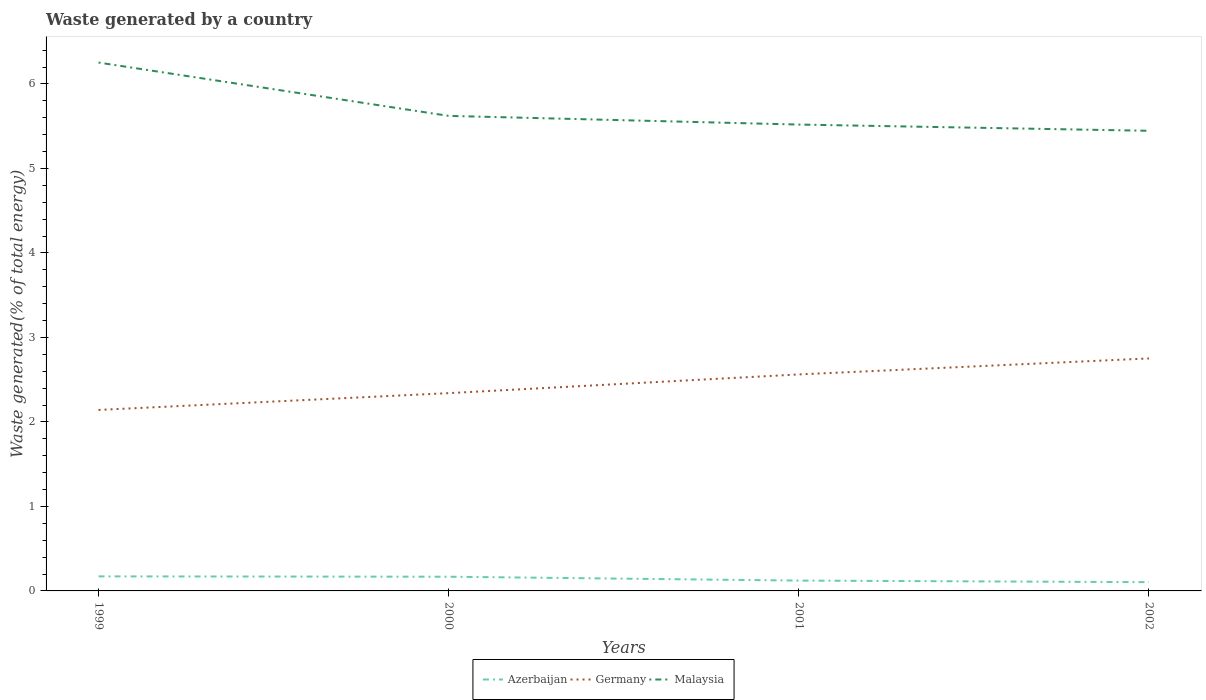Does the line corresponding to Germany intersect with the line corresponding to Azerbaijan?
Your answer should be compact. No. Across all years, what is the maximum total waste generated in Germany?
Ensure brevity in your answer.  2.14. What is the total total waste generated in Malaysia in the graph?
Your response must be concise. 0.63. What is the difference between the highest and the second highest total waste generated in Malaysia?
Your answer should be compact. 0.81. What is the difference between the highest and the lowest total waste generated in Germany?
Offer a very short reply. 2. How many lines are there?
Provide a succinct answer. 3. How many years are there in the graph?
Provide a short and direct response. 4. Are the values on the major ticks of Y-axis written in scientific E-notation?
Make the answer very short. No. Does the graph contain any zero values?
Provide a short and direct response. No. Does the graph contain grids?
Your answer should be very brief. No. Where does the legend appear in the graph?
Offer a terse response. Bottom center. What is the title of the graph?
Your response must be concise. Waste generated by a country. Does "Faeroe Islands" appear as one of the legend labels in the graph?
Offer a terse response. No. What is the label or title of the X-axis?
Your response must be concise. Years. What is the label or title of the Y-axis?
Give a very brief answer. Waste generated(% of total energy). What is the Waste generated(% of total energy) of Azerbaijan in 1999?
Your response must be concise. 0.17. What is the Waste generated(% of total energy) in Germany in 1999?
Your answer should be very brief. 2.14. What is the Waste generated(% of total energy) of Malaysia in 1999?
Offer a terse response. 6.25. What is the Waste generated(% of total energy) of Azerbaijan in 2000?
Your answer should be very brief. 0.17. What is the Waste generated(% of total energy) in Germany in 2000?
Provide a succinct answer. 2.34. What is the Waste generated(% of total energy) in Malaysia in 2000?
Your answer should be very brief. 5.62. What is the Waste generated(% of total energy) of Azerbaijan in 2001?
Offer a very short reply. 0.12. What is the Waste generated(% of total energy) in Germany in 2001?
Ensure brevity in your answer.  2.56. What is the Waste generated(% of total energy) in Malaysia in 2001?
Your answer should be very brief. 5.52. What is the Waste generated(% of total energy) of Azerbaijan in 2002?
Provide a succinct answer. 0.1. What is the Waste generated(% of total energy) of Germany in 2002?
Provide a succinct answer. 2.75. What is the Waste generated(% of total energy) of Malaysia in 2002?
Your response must be concise. 5.45. Across all years, what is the maximum Waste generated(% of total energy) of Azerbaijan?
Your response must be concise. 0.17. Across all years, what is the maximum Waste generated(% of total energy) in Germany?
Provide a succinct answer. 2.75. Across all years, what is the maximum Waste generated(% of total energy) in Malaysia?
Keep it short and to the point. 6.25. Across all years, what is the minimum Waste generated(% of total energy) in Azerbaijan?
Provide a short and direct response. 0.1. Across all years, what is the minimum Waste generated(% of total energy) of Germany?
Ensure brevity in your answer.  2.14. Across all years, what is the minimum Waste generated(% of total energy) in Malaysia?
Provide a short and direct response. 5.45. What is the total Waste generated(% of total energy) of Azerbaijan in the graph?
Your answer should be very brief. 0.57. What is the total Waste generated(% of total energy) of Germany in the graph?
Keep it short and to the point. 9.8. What is the total Waste generated(% of total energy) of Malaysia in the graph?
Keep it short and to the point. 22.84. What is the difference between the Waste generated(% of total energy) in Azerbaijan in 1999 and that in 2000?
Offer a very short reply. 0. What is the difference between the Waste generated(% of total energy) in Germany in 1999 and that in 2000?
Keep it short and to the point. -0.2. What is the difference between the Waste generated(% of total energy) in Malaysia in 1999 and that in 2000?
Ensure brevity in your answer.  0.63. What is the difference between the Waste generated(% of total energy) in Azerbaijan in 1999 and that in 2001?
Ensure brevity in your answer.  0.05. What is the difference between the Waste generated(% of total energy) in Germany in 1999 and that in 2001?
Give a very brief answer. -0.42. What is the difference between the Waste generated(% of total energy) of Malaysia in 1999 and that in 2001?
Ensure brevity in your answer.  0.73. What is the difference between the Waste generated(% of total energy) in Azerbaijan in 1999 and that in 2002?
Your answer should be compact. 0.07. What is the difference between the Waste generated(% of total energy) in Germany in 1999 and that in 2002?
Provide a short and direct response. -0.61. What is the difference between the Waste generated(% of total energy) of Malaysia in 1999 and that in 2002?
Keep it short and to the point. 0.81. What is the difference between the Waste generated(% of total energy) in Azerbaijan in 2000 and that in 2001?
Make the answer very short. 0.05. What is the difference between the Waste generated(% of total energy) of Germany in 2000 and that in 2001?
Make the answer very short. -0.22. What is the difference between the Waste generated(% of total energy) in Malaysia in 2000 and that in 2001?
Give a very brief answer. 0.1. What is the difference between the Waste generated(% of total energy) of Azerbaijan in 2000 and that in 2002?
Make the answer very short. 0.06. What is the difference between the Waste generated(% of total energy) in Germany in 2000 and that in 2002?
Offer a very short reply. -0.41. What is the difference between the Waste generated(% of total energy) of Malaysia in 2000 and that in 2002?
Ensure brevity in your answer.  0.18. What is the difference between the Waste generated(% of total energy) of Azerbaijan in 2001 and that in 2002?
Keep it short and to the point. 0.02. What is the difference between the Waste generated(% of total energy) of Germany in 2001 and that in 2002?
Your answer should be compact. -0.19. What is the difference between the Waste generated(% of total energy) of Malaysia in 2001 and that in 2002?
Provide a short and direct response. 0.07. What is the difference between the Waste generated(% of total energy) in Azerbaijan in 1999 and the Waste generated(% of total energy) in Germany in 2000?
Provide a short and direct response. -2.17. What is the difference between the Waste generated(% of total energy) in Azerbaijan in 1999 and the Waste generated(% of total energy) in Malaysia in 2000?
Your response must be concise. -5.45. What is the difference between the Waste generated(% of total energy) in Germany in 1999 and the Waste generated(% of total energy) in Malaysia in 2000?
Your response must be concise. -3.48. What is the difference between the Waste generated(% of total energy) of Azerbaijan in 1999 and the Waste generated(% of total energy) of Germany in 2001?
Offer a terse response. -2.39. What is the difference between the Waste generated(% of total energy) in Azerbaijan in 1999 and the Waste generated(% of total energy) in Malaysia in 2001?
Make the answer very short. -5.35. What is the difference between the Waste generated(% of total energy) of Germany in 1999 and the Waste generated(% of total energy) of Malaysia in 2001?
Provide a succinct answer. -3.38. What is the difference between the Waste generated(% of total energy) of Azerbaijan in 1999 and the Waste generated(% of total energy) of Germany in 2002?
Provide a short and direct response. -2.58. What is the difference between the Waste generated(% of total energy) in Azerbaijan in 1999 and the Waste generated(% of total energy) in Malaysia in 2002?
Provide a succinct answer. -5.27. What is the difference between the Waste generated(% of total energy) of Germany in 1999 and the Waste generated(% of total energy) of Malaysia in 2002?
Your answer should be very brief. -3.3. What is the difference between the Waste generated(% of total energy) in Azerbaijan in 2000 and the Waste generated(% of total energy) in Germany in 2001?
Provide a succinct answer. -2.39. What is the difference between the Waste generated(% of total energy) in Azerbaijan in 2000 and the Waste generated(% of total energy) in Malaysia in 2001?
Your response must be concise. -5.35. What is the difference between the Waste generated(% of total energy) in Germany in 2000 and the Waste generated(% of total energy) in Malaysia in 2001?
Your response must be concise. -3.18. What is the difference between the Waste generated(% of total energy) of Azerbaijan in 2000 and the Waste generated(% of total energy) of Germany in 2002?
Give a very brief answer. -2.58. What is the difference between the Waste generated(% of total energy) in Azerbaijan in 2000 and the Waste generated(% of total energy) in Malaysia in 2002?
Offer a very short reply. -5.28. What is the difference between the Waste generated(% of total energy) in Germany in 2000 and the Waste generated(% of total energy) in Malaysia in 2002?
Offer a very short reply. -3.1. What is the difference between the Waste generated(% of total energy) in Azerbaijan in 2001 and the Waste generated(% of total energy) in Germany in 2002?
Your response must be concise. -2.63. What is the difference between the Waste generated(% of total energy) in Azerbaijan in 2001 and the Waste generated(% of total energy) in Malaysia in 2002?
Ensure brevity in your answer.  -5.32. What is the difference between the Waste generated(% of total energy) of Germany in 2001 and the Waste generated(% of total energy) of Malaysia in 2002?
Make the answer very short. -2.88. What is the average Waste generated(% of total energy) in Azerbaijan per year?
Ensure brevity in your answer.  0.14. What is the average Waste generated(% of total energy) of Germany per year?
Provide a short and direct response. 2.45. What is the average Waste generated(% of total energy) of Malaysia per year?
Your response must be concise. 5.71. In the year 1999, what is the difference between the Waste generated(% of total energy) in Azerbaijan and Waste generated(% of total energy) in Germany?
Give a very brief answer. -1.97. In the year 1999, what is the difference between the Waste generated(% of total energy) of Azerbaijan and Waste generated(% of total energy) of Malaysia?
Offer a very short reply. -6.08. In the year 1999, what is the difference between the Waste generated(% of total energy) in Germany and Waste generated(% of total energy) in Malaysia?
Your response must be concise. -4.11. In the year 2000, what is the difference between the Waste generated(% of total energy) in Azerbaijan and Waste generated(% of total energy) in Germany?
Your answer should be compact. -2.17. In the year 2000, what is the difference between the Waste generated(% of total energy) in Azerbaijan and Waste generated(% of total energy) in Malaysia?
Ensure brevity in your answer.  -5.45. In the year 2000, what is the difference between the Waste generated(% of total energy) in Germany and Waste generated(% of total energy) in Malaysia?
Keep it short and to the point. -3.28. In the year 2001, what is the difference between the Waste generated(% of total energy) in Azerbaijan and Waste generated(% of total energy) in Germany?
Offer a very short reply. -2.44. In the year 2001, what is the difference between the Waste generated(% of total energy) in Azerbaijan and Waste generated(% of total energy) in Malaysia?
Provide a succinct answer. -5.4. In the year 2001, what is the difference between the Waste generated(% of total energy) in Germany and Waste generated(% of total energy) in Malaysia?
Keep it short and to the point. -2.96. In the year 2002, what is the difference between the Waste generated(% of total energy) in Azerbaijan and Waste generated(% of total energy) in Germany?
Provide a short and direct response. -2.65. In the year 2002, what is the difference between the Waste generated(% of total energy) of Azerbaijan and Waste generated(% of total energy) of Malaysia?
Provide a short and direct response. -5.34. In the year 2002, what is the difference between the Waste generated(% of total energy) of Germany and Waste generated(% of total energy) of Malaysia?
Your answer should be very brief. -2.69. What is the ratio of the Waste generated(% of total energy) in Azerbaijan in 1999 to that in 2000?
Give a very brief answer. 1.02. What is the ratio of the Waste generated(% of total energy) in Germany in 1999 to that in 2000?
Provide a succinct answer. 0.92. What is the ratio of the Waste generated(% of total energy) in Malaysia in 1999 to that in 2000?
Your answer should be compact. 1.11. What is the ratio of the Waste generated(% of total energy) in Azerbaijan in 1999 to that in 2001?
Make the answer very short. 1.41. What is the ratio of the Waste generated(% of total energy) in Germany in 1999 to that in 2001?
Make the answer very short. 0.84. What is the ratio of the Waste generated(% of total energy) in Malaysia in 1999 to that in 2001?
Ensure brevity in your answer.  1.13. What is the ratio of the Waste generated(% of total energy) in Azerbaijan in 1999 to that in 2002?
Make the answer very short. 1.66. What is the ratio of the Waste generated(% of total energy) in Germany in 1999 to that in 2002?
Your response must be concise. 0.78. What is the ratio of the Waste generated(% of total energy) of Malaysia in 1999 to that in 2002?
Your answer should be very brief. 1.15. What is the ratio of the Waste generated(% of total energy) of Azerbaijan in 2000 to that in 2001?
Make the answer very short. 1.37. What is the ratio of the Waste generated(% of total energy) in Germany in 2000 to that in 2001?
Ensure brevity in your answer.  0.91. What is the ratio of the Waste generated(% of total energy) in Malaysia in 2000 to that in 2001?
Ensure brevity in your answer.  1.02. What is the ratio of the Waste generated(% of total energy) of Azerbaijan in 2000 to that in 2002?
Your response must be concise. 1.62. What is the ratio of the Waste generated(% of total energy) of Germany in 2000 to that in 2002?
Ensure brevity in your answer.  0.85. What is the ratio of the Waste generated(% of total energy) of Malaysia in 2000 to that in 2002?
Provide a succinct answer. 1.03. What is the ratio of the Waste generated(% of total energy) of Azerbaijan in 2001 to that in 2002?
Provide a short and direct response. 1.18. What is the ratio of the Waste generated(% of total energy) of Germany in 2001 to that in 2002?
Your response must be concise. 0.93. What is the ratio of the Waste generated(% of total energy) in Malaysia in 2001 to that in 2002?
Your answer should be compact. 1.01. What is the difference between the highest and the second highest Waste generated(% of total energy) in Azerbaijan?
Make the answer very short. 0. What is the difference between the highest and the second highest Waste generated(% of total energy) in Germany?
Keep it short and to the point. 0.19. What is the difference between the highest and the second highest Waste generated(% of total energy) in Malaysia?
Give a very brief answer. 0.63. What is the difference between the highest and the lowest Waste generated(% of total energy) of Azerbaijan?
Offer a terse response. 0.07. What is the difference between the highest and the lowest Waste generated(% of total energy) of Germany?
Offer a very short reply. 0.61. What is the difference between the highest and the lowest Waste generated(% of total energy) in Malaysia?
Your answer should be compact. 0.81. 